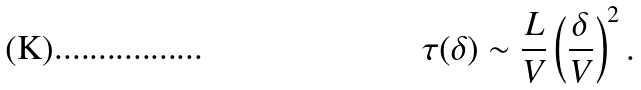<formula> <loc_0><loc_0><loc_500><loc_500>\tau ( \delta ) \sim \frac { L } { V } \left ( \frac { \delta } { V } \right ) ^ { 2 } .</formula> 